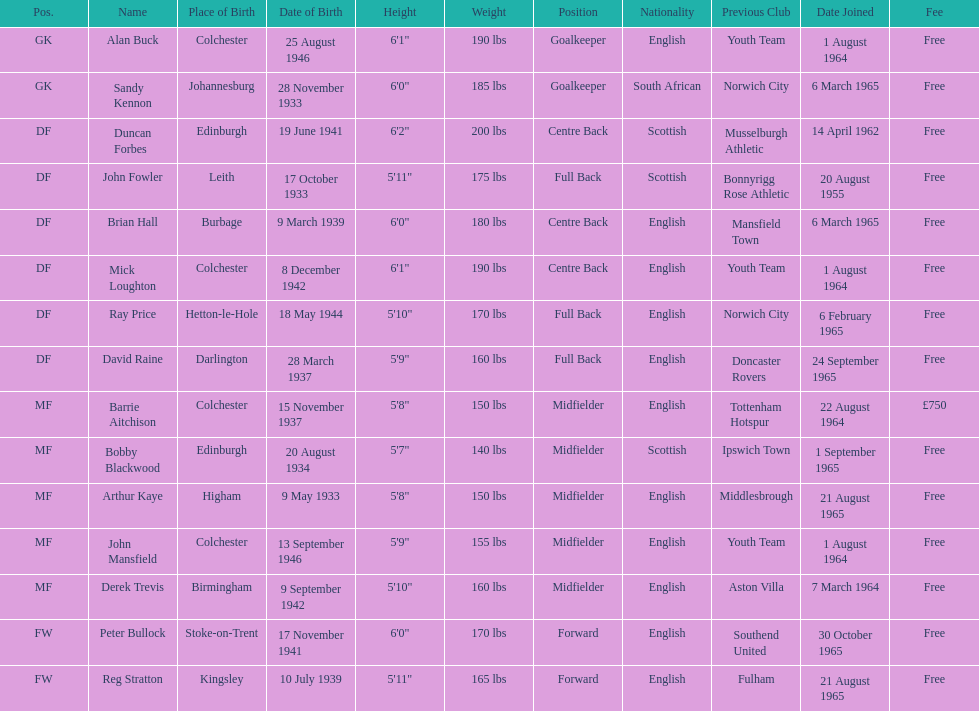Is arthur kaye older or younger than brian hill? Older. 